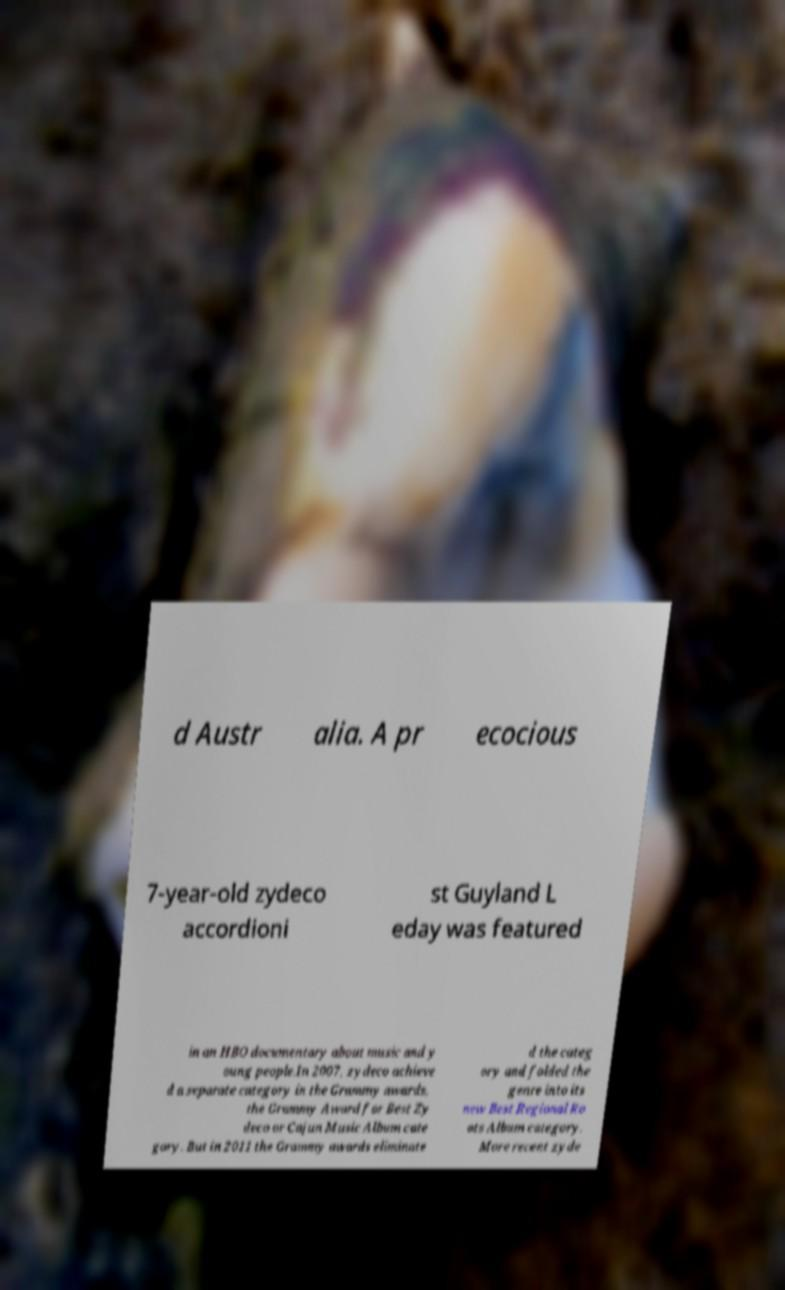Could you extract and type out the text from this image? d Austr alia. A pr ecocious 7-year-old zydeco accordioni st Guyland L eday was featured in an HBO documentary about music and y oung people.In 2007, zydeco achieve d a separate category in the Grammy awards, the Grammy Award for Best Zy deco or Cajun Music Album cate gory. But in 2011 the Grammy awards eliminate d the categ ory and folded the genre into its new Best Regional Ro ots Album category. More recent zyde 